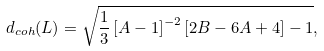<formula> <loc_0><loc_0><loc_500><loc_500>d _ { c o h } ( L ) = \sqrt { \frac { 1 } { 3 } \left [ A - 1 \right ] ^ { - 2 } \left [ 2 B - 6 A + 4 \right ] - 1 } ,</formula> 